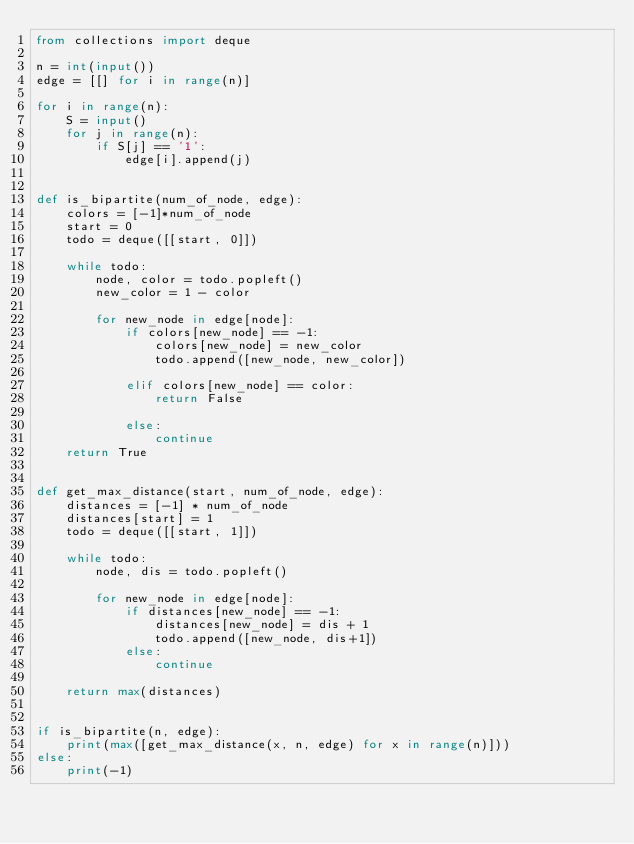<code> <loc_0><loc_0><loc_500><loc_500><_Python_>from collections import deque

n = int(input())
edge = [[] for i in range(n)]

for i in range(n):
    S = input()
    for j in range(n):
        if S[j] == '1':
            edge[i].append(j)


def is_bipartite(num_of_node, edge):
    colors = [-1]*num_of_node
    start = 0
    todo = deque([[start, 0]])

    while todo:
        node, color = todo.popleft()
        new_color = 1 - color

        for new_node in edge[node]:
            if colors[new_node] == -1:
                colors[new_node] = new_color
                todo.append([new_node, new_color])

            elif colors[new_node] == color:
                return False

            else:
                continue
    return True


def get_max_distance(start, num_of_node, edge):
    distances = [-1] * num_of_node
    distances[start] = 1
    todo = deque([[start, 1]])

    while todo:
        node, dis = todo.popleft()

        for new_node in edge[node]:
            if distances[new_node] == -1:
                distances[new_node] = dis + 1
                todo.append([new_node, dis+1])
            else:
                continue

    return max(distances)


if is_bipartite(n, edge):
    print(max([get_max_distance(x, n, edge) for x in range(n)]))
else:
    print(-1)</code> 